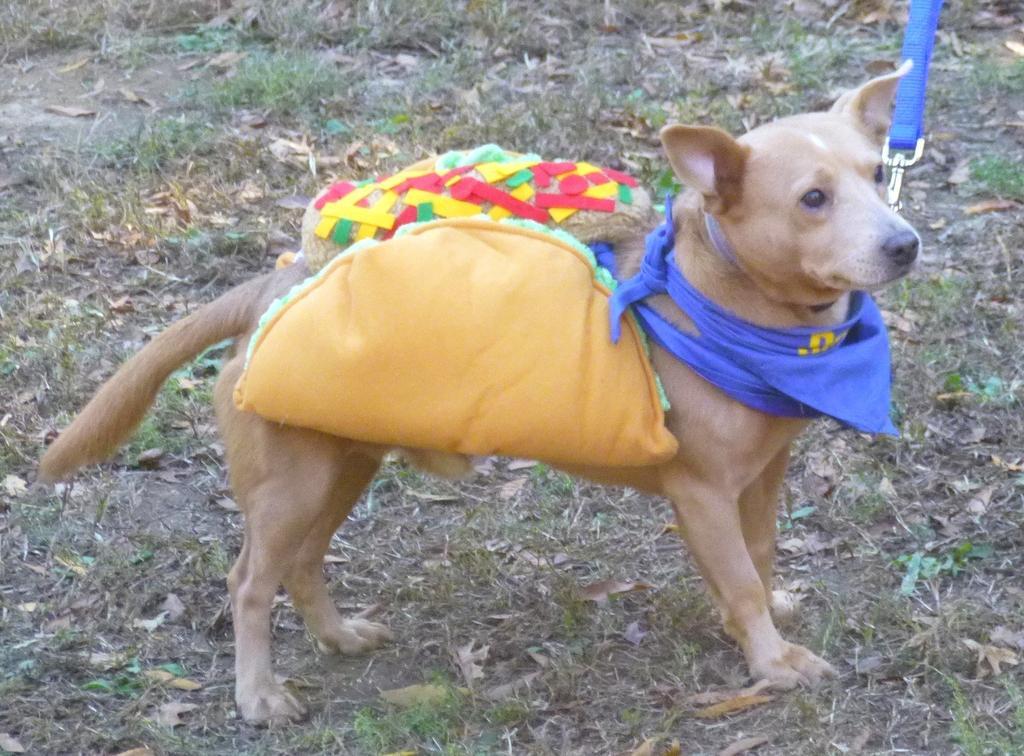Could you give a brief overview of what you see in this image? In this picture we can see a dog is standing in the front, this dog is carrying clothes, we can see a strap on its neck, there are some leaves and grass at the bottom. 